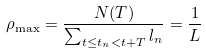Convert formula to latex. <formula><loc_0><loc_0><loc_500><loc_500>\rho _ { \max } = \frac { N ( T ) } { \sum _ { t \leq t _ { n } < t + T } l _ { n } } = \frac { 1 } { L }</formula> 